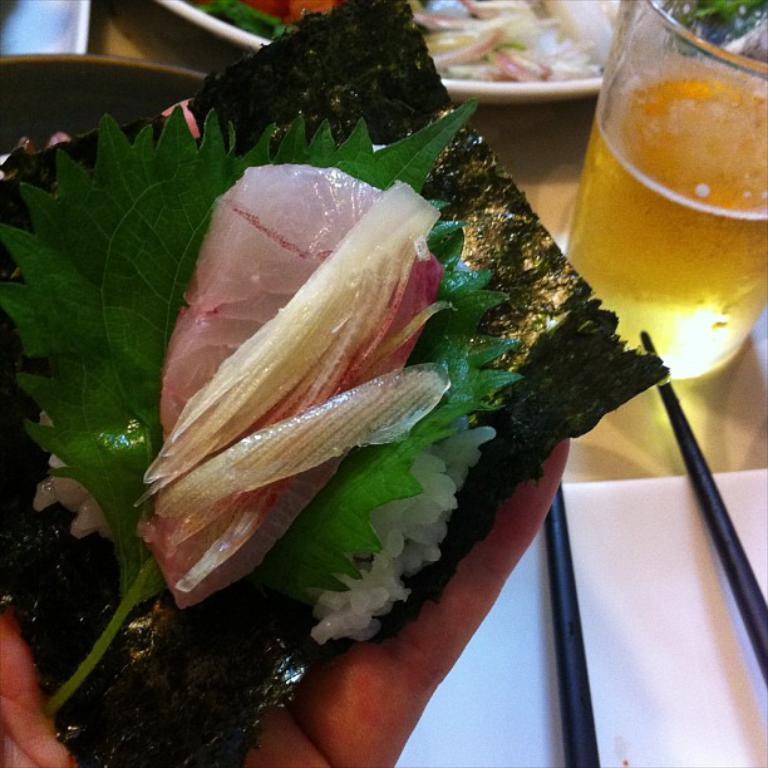Please provide a concise description of this image. In this image I can see the person holding the food and the food is in white color. In the background I can see the glass and few objects on the table. 